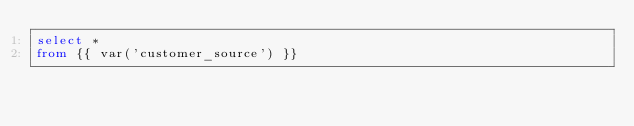Convert code to text. <code><loc_0><loc_0><loc_500><loc_500><_SQL_>select * 
from {{ var('customer_source') }}</code> 